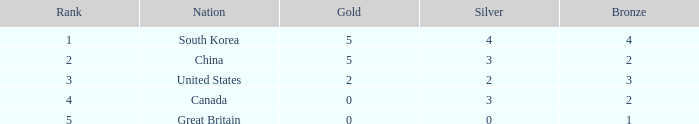What is the average Silver, when Rank is 5, and when Bronze is less than 1? None. 